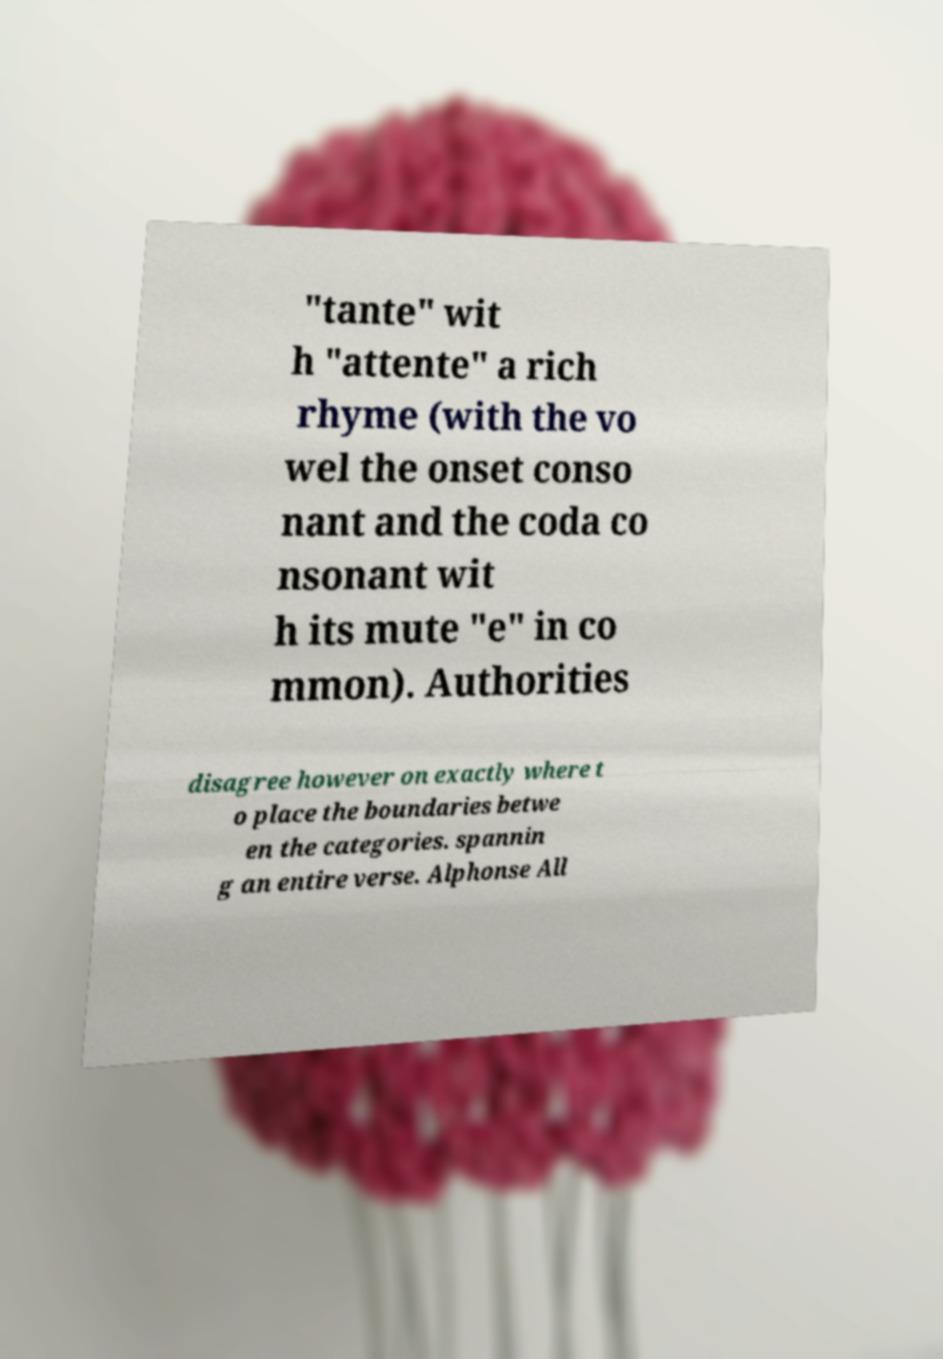Can you accurately transcribe the text from the provided image for me? "tante" wit h "attente" a rich rhyme (with the vo wel the onset conso nant and the coda co nsonant wit h its mute "e" in co mmon). Authorities disagree however on exactly where t o place the boundaries betwe en the categories. spannin g an entire verse. Alphonse All 